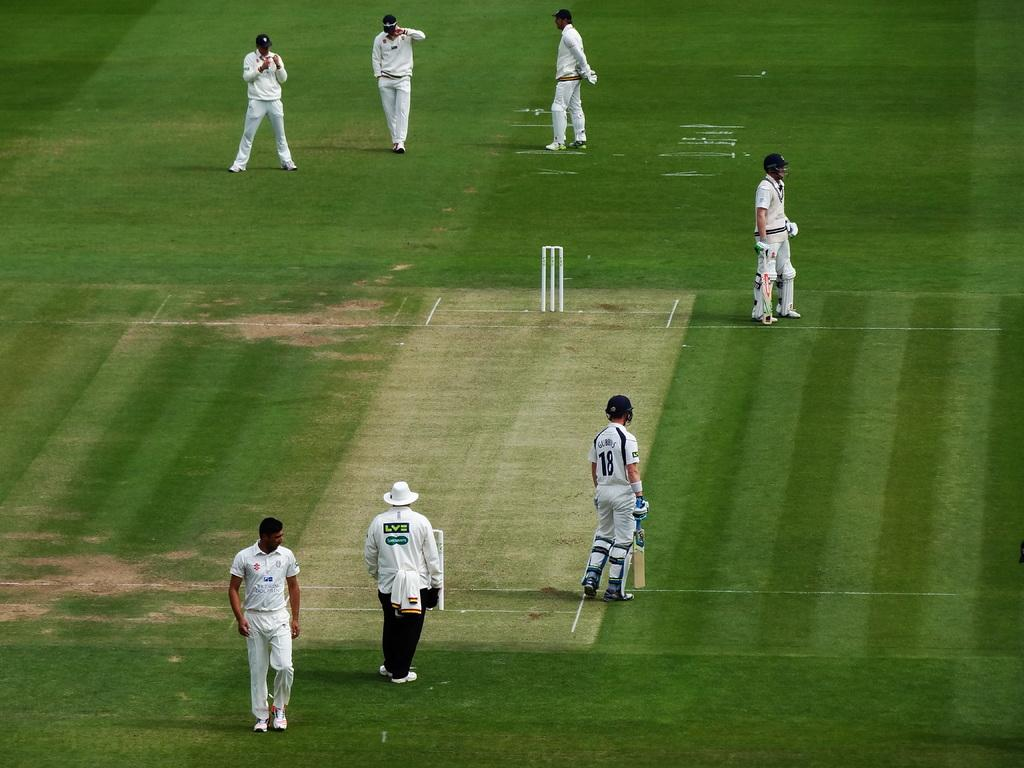<image>
Share a concise interpretation of the image provided. a player on a field has the number 18 on their back 